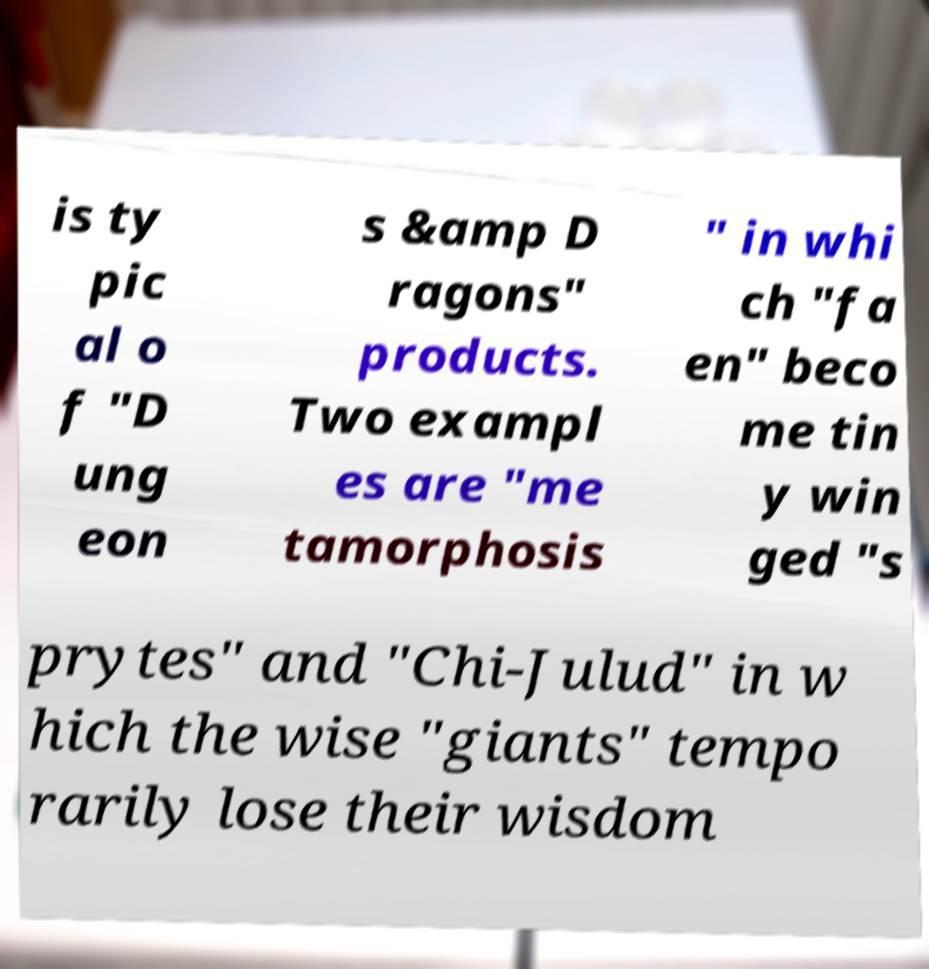Could you extract and type out the text from this image? is ty pic al o f "D ung eon s &amp D ragons" products. Two exampl es are "me tamorphosis " in whi ch "fa en" beco me tin y win ged "s prytes" and "Chi-Julud" in w hich the wise "giants" tempo rarily lose their wisdom 